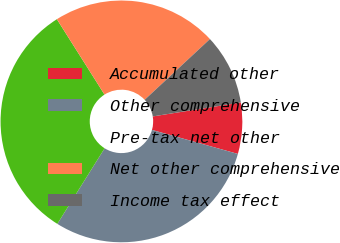<chart> <loc_0><loc_0><loc_500><loc_500><pie_chart><fcel>Accumulated other<fcel>Other comprehensive<fcel>Pre-tax net other<fcel>Net other comprehensive<fcel>Income tax effect<nl><fcel>6.84%<fcel>29.56%<fcel>32.13%<fcel>22.04%<fcel>9.42%<nl></chart> 